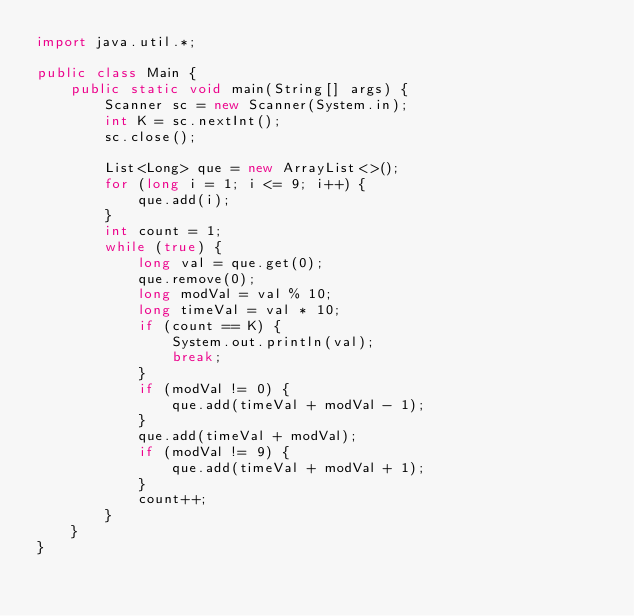Convert code to text. <code><loc_0><loc_0><loc_500><loc_500><_Java_>import java.util.*;

public class Main {
    public static void main(String[] args) {
        Scanner sc = new Scanner(System.in);
        int K = sc.nextInt();
        sc.close();

        List<Long> que = new ArrayList<>();
        for (long i = 1; i <= 9; i++) {
            que.add(i);
        }
        int count = 1;
        while (true) {
            long val = que.get(0);
            que.remove(0);
            long modVal = val % 10;
            long timeVal = val * 10;
            if (count == K) {
                System.out.println(val);
                break;
            }
            if (modVal != 0) {
                que.add(timeVal + modVal - 1);
            }
            que.add(timeVal + modVal);
            if (modVal != 9) {
                que.add(timeVal + modVal + 1);
            }
            count++;
        }
    }
}
</code> 